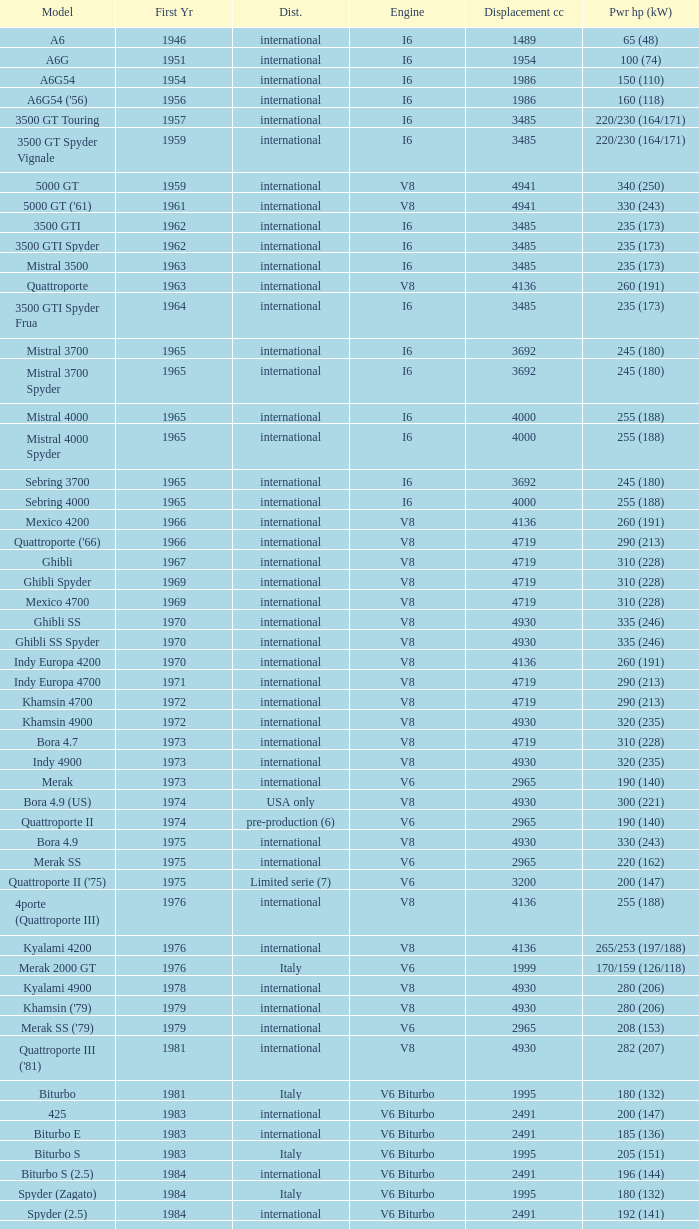What is the lowest First Year, when Model is "Quattroporte (2.8)"? 1994.0. 